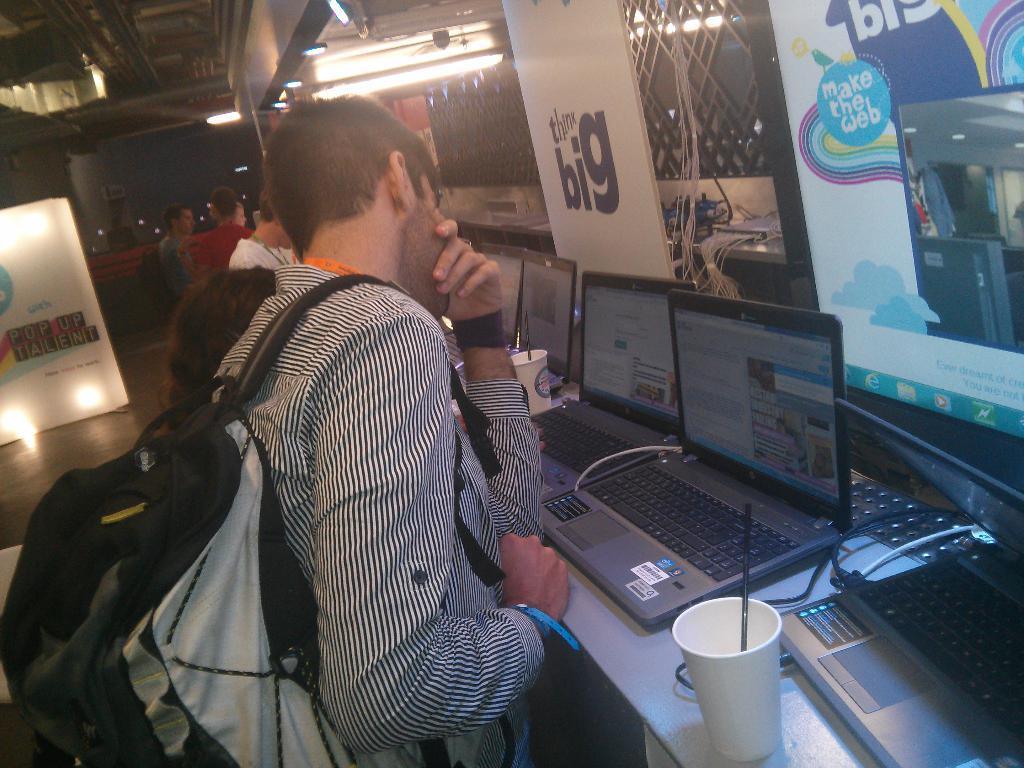Can you describe this image briefly? In this image we can see many people in the image. There are few people are standing near the desk. A person is wearing a backpack. There are many laptops on the desk. There are many objects on the table. There are many cables in the image. There are advertising boards and lights in the image. 